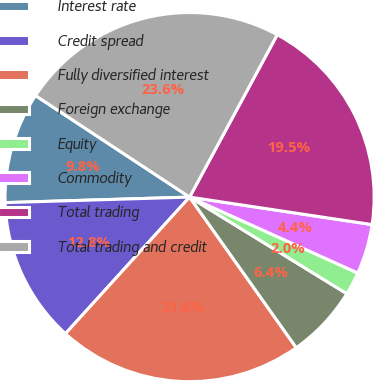<chart> <loc_0><loc_0><loc_500><loc_500><pie_chart><fcel>Interest rate<fcel>Credit spread<fcel>Fully diversified interest<fcel>Foreign exchange<fcel>Equity<fcel>Commodity<fcel>Total trading<fcel>Total trading and credit<nl><fcel>9.75%<fcel>12.78%<fcel>21.55%<fcel>6.42%<fcel>2.02%<fcel>4.37%<fcel>19.5%<fcel>23.6%<nl></chart> 